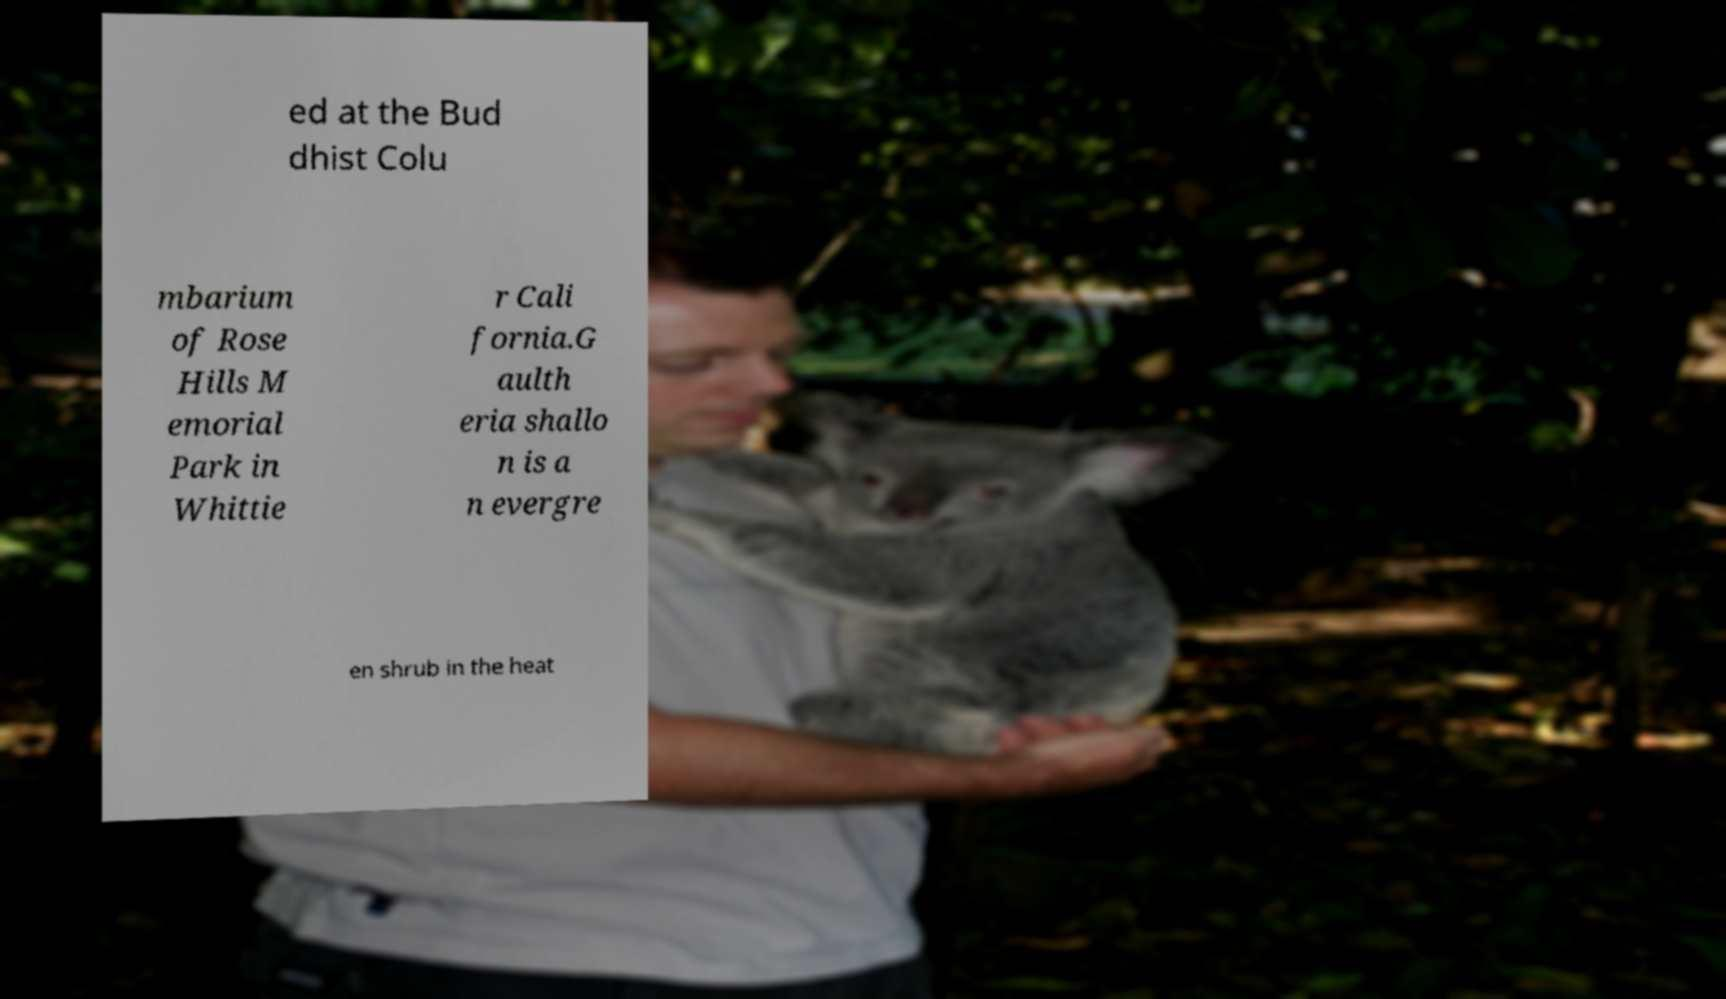Can you read and provide the text displayed in the image?This photo seems to have some interesting text. Can you extract and type it out for me? ed at the Bud dhist Colu mbarium of Rose Hills M emorial Park in Whittie r Cali fornia.G aulth eria shallo n is a n evergre en shrub in the heat 